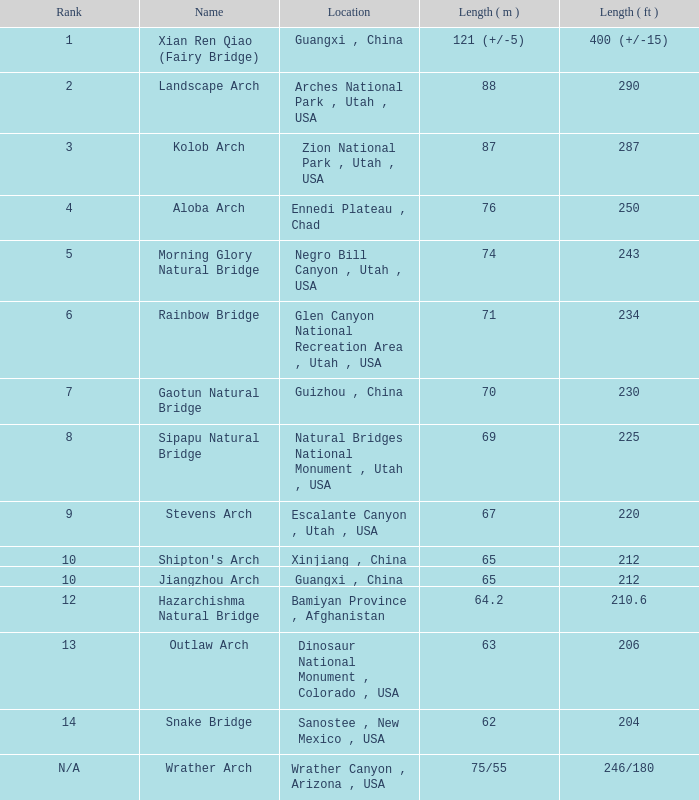Parse the table in full. {'header': ['Rank', 'Name', 'Location', 'Length ( m )', 'Length ( ft )'], 'rows': [['1', 'Xian Ren Qiao (Fairy Bridge)', 'Guangxi , China', '121 (+/-5)', '400 (+/-15)'], ['2', 'Landscape Arch', 'Arches National Park , Utah , USA', '88', '290'], ['3', 'Kolob Arch', 'Zion National Park , Utah , USA', '87', '287'], ['4', 'Aloba Arch', 'Ennedi Plateau , Chad', '76', '250'], ['5', 'Morning Glory Natural Bridge', 'Negro Bill Canyon , Utah , USA', '74', '243'], ['6', 'Rainbow Bridge', 'Glen Canyon National Recreation Area , Utah , USA', '71', '234'], ['7', 'Gaotun Natural Bridge', 'Guizhou , China', '70', '230'], ['8', 'Sipapu Natural Bridge', 'Natural Bridges National Monument , Utah , USA', '69', '225'], ['9', 'Stevens Arch', 'Escalante Canyon , Utah , USA', '67', '220'], ['10', "Shipton's Arch", 'Xinjiang , China', '65', '212'], ['10', 'Jiangzhou Arch', 'Guangxi , China', '65', '212'], ['12', 'Hazarchishma Natural Bridge', 'Bamiyan Province , Afghanistan', '64.2', '210.6'], ['13', 'Outlaw Arch', 'Dinosaur National Monument , Colorado , USA', '63', '206'], ['14', 'Snake Bridge', 'Sanostee , New Mexico , USA', '62', '204'], ['N/A', 'Wrather Arch', 'Wrather Canyon , Arizona , USA', '75/55', '246/180']]} Where does the longest arch, having a length of 63 meters, exist? Dinosaur National Monument , Colorado , USA. 